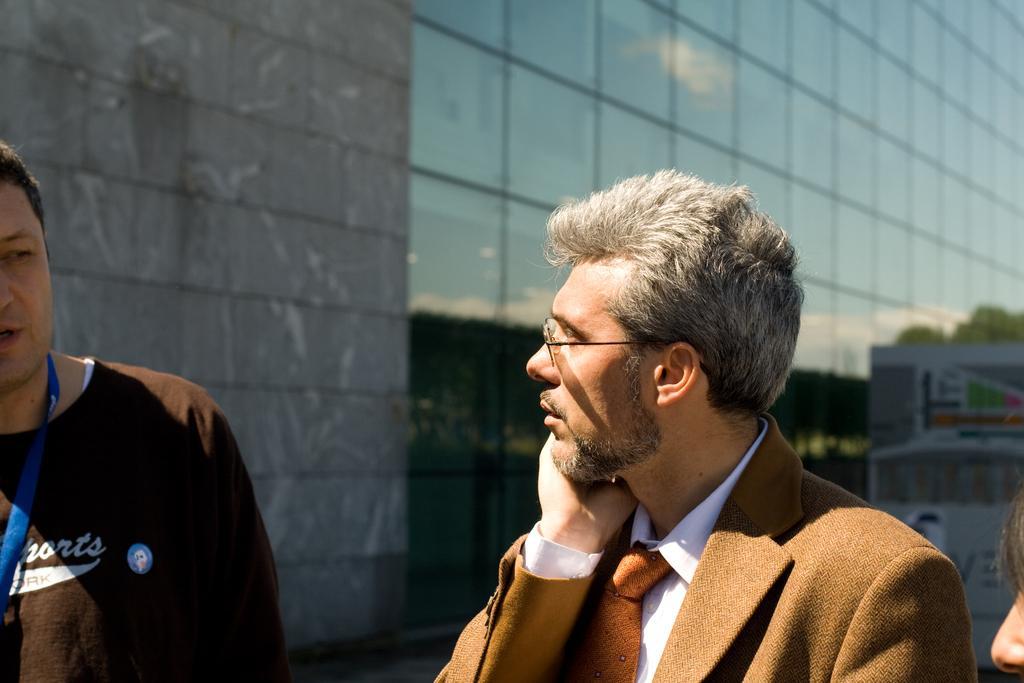Describe this image in one or two sentences. In this image we can see people. In the background there is a building. On the right there is a board. 